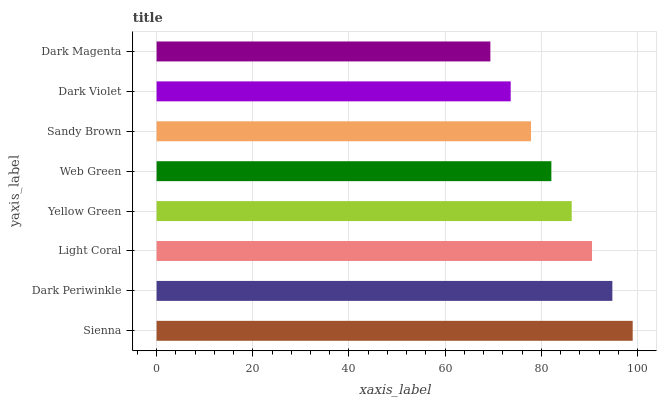Is Dark Magenta the minimum?
Answer yes or no. Yes. Is Sienna the maximum?
Answer yes or no. Yes. Is Dark Periwinkle the minimum?
Answer yes or no. No. Is Dark Periwinkle the maximum?
Answer yes or no. No. Is Sienna greater than Dark Periwinkle?
Answer yes or no. Yes. Is Dark Periwinkle less than Sienna?
Answer yes or no. Yes. Is Dark Periwinkle greater than Sienna?
Answer yes or no. No. Is Sienna less than Dark Periwinkle?
Answer yes or no. No. Is Yellow Green the high median?
Answer yes or no. Yes. Is Web Green the low median?
Answer yes or no. Yes. Is Light Coral the high median?
Answer yes or no. No. Is Dark Periwinkle the low median?
Answer yes or no. No. 